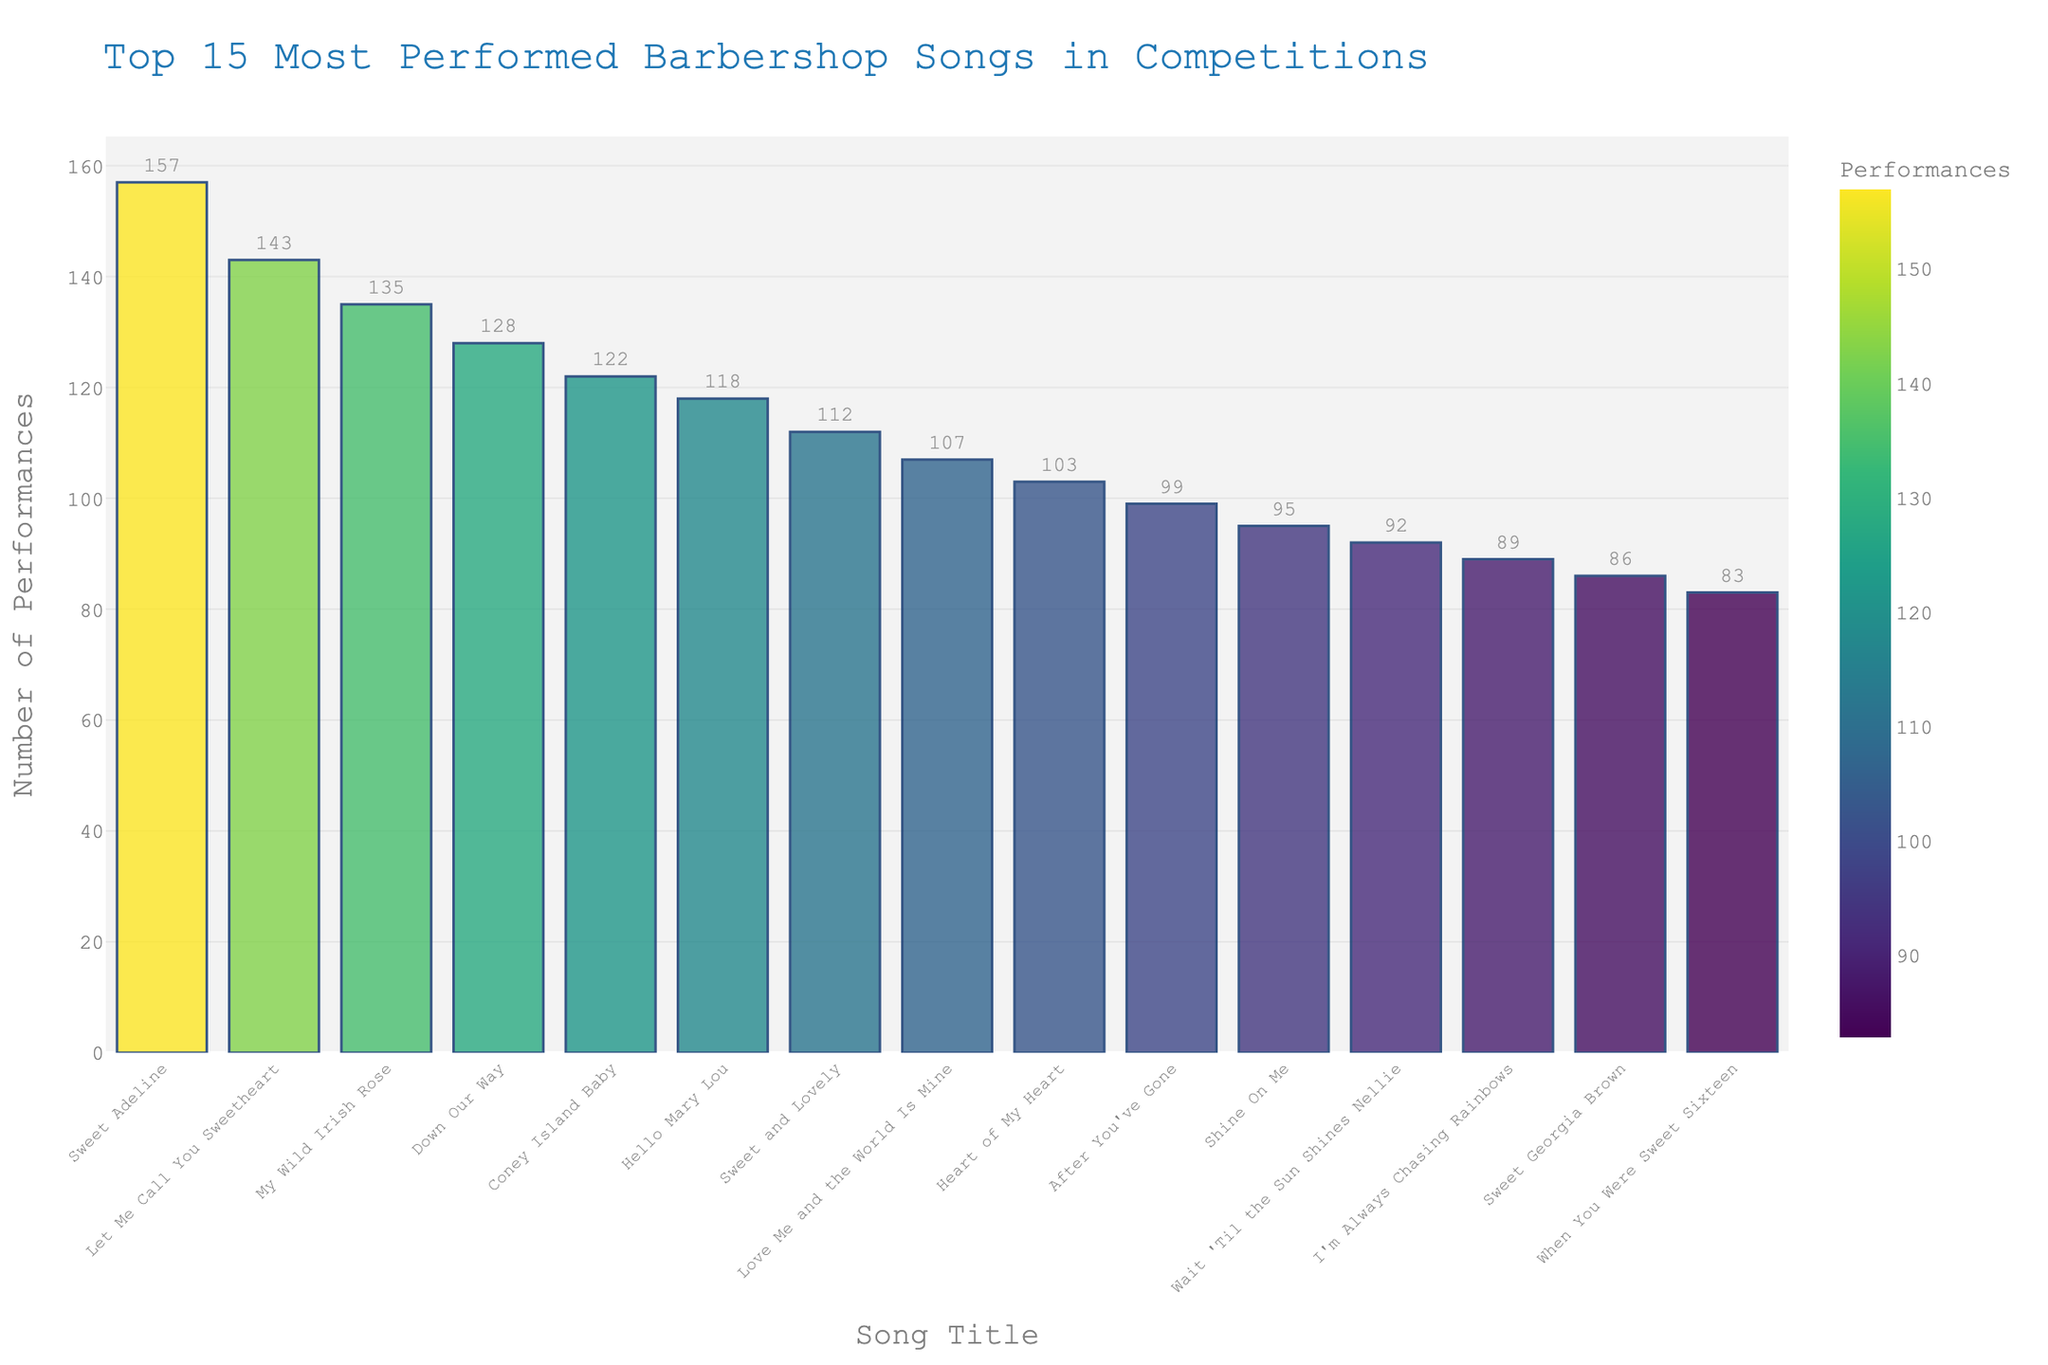Which song is performed the most in competitions? The bar chart shows that "Sweet Adeline" has the highest frequency, towering over the other bars.
Answer: Sweet Adeline Which song is performed less often: "Coney Island Baby" or "Hello Mary Lou"? The bar for "Coney Island Baby" is slightly taller than the one for "Hello Mary Lou", indicating it has been performed more frequently.
Answer: Hello Mary Lou What’s the difference in the number of performances between the most and least performed songs in the top 15? The most performed song "Sweet Adeline" has 157 performances, while the least performed song "When You Were Sweet Sixteen" has 83 performances. Subtracting these numbers gives: 157 - 83 = 74.
Answer: 74 Which two songs have a combined total of over 270 performances? "Sweet Adeline" (157) and "Let Me Call You Sweetheart" (143) are the only pairs whose combined total is: 157 + 143 = 300, which is over 270.
Answer: Sweet Adeline and Let Me Call You Sweetheart Is "Sweet Adeline" performed more than "My Wild Irish Rose" and "Down Our Way" combined? "My Wild Irish Rose" has 135 performances, and "Down Our Way" has 128 performances. Combined, they have 135 + 128 = 263 performances, which is more than "Sweet Adeline" with 157 performances.
Answer: No Which song shows a higher performance frequency: "Love Me and the World Is Mine" or "Heart of My Heart"? The bar representing "Love Me and the World Is Mine" is taller than the bar for "Heart of My Heart" on the chart.
Answer: Love Me and the World Is Mine Determine the average number of performances for the top 5 most performed songs. The performances for the top 5 songs are 157, 143, 135, 128, and 122. Adding them gives 157 + 143 + 135 + 128 + 122 = 685. Dividing by 5 gives the average: 685 / 5 = 137.
Answer: 137 Comparing "Hello Mary Lou" and "Sweet and Lovely", which song is performed fewer times? By observing the heights of the bars, "Sweet and Lovely" has a higher bar than "Hello Mary Lou", indicating more performances.
Answer: Hello Mary Lou What is the total number of performances for "After You've Gone" and "Shine On Me"? "After You've Gone" has 99 performances, and "Shine On Me" has 95 performances. Adding these gives 99 + 95 = 194.
Answer: 194 Which song is closer in performance count to "Wait 'Til the Sun Shines Nellie", "Sweet Georgia Brown" or "I'm Always Chasing Rainbows"? "Wait 'Til the Sun Shines Nellie" has 92 performances, "I'm Always Chasing Rainbows" has 89 performances and "Sweet Georgia Brown" has 86 performances. 92 is closer to 89.
Answer: I'm Always Chasing Rainbows 